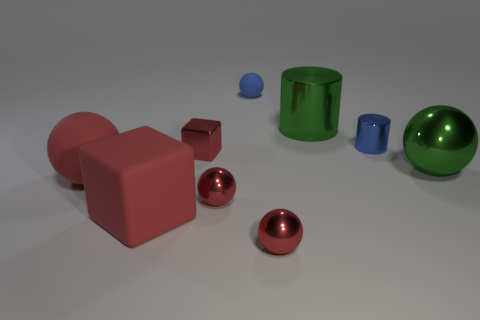How does the lighting in the scene affect the appearance of the objects? The lighting in the scene is soft and diffused, casting gentle shadows and highlighting the shapes and materials of the objects. It enhances the three-dimensional aspect of the objects and provides visual cues about their texture and material properties. Which object in the scene seems to reflect light the most? The glossy green sphere on the right seems to reflect light the most. Its shiny surface acts like a mirror, reflecting the environment and the light sources with high clarity. 